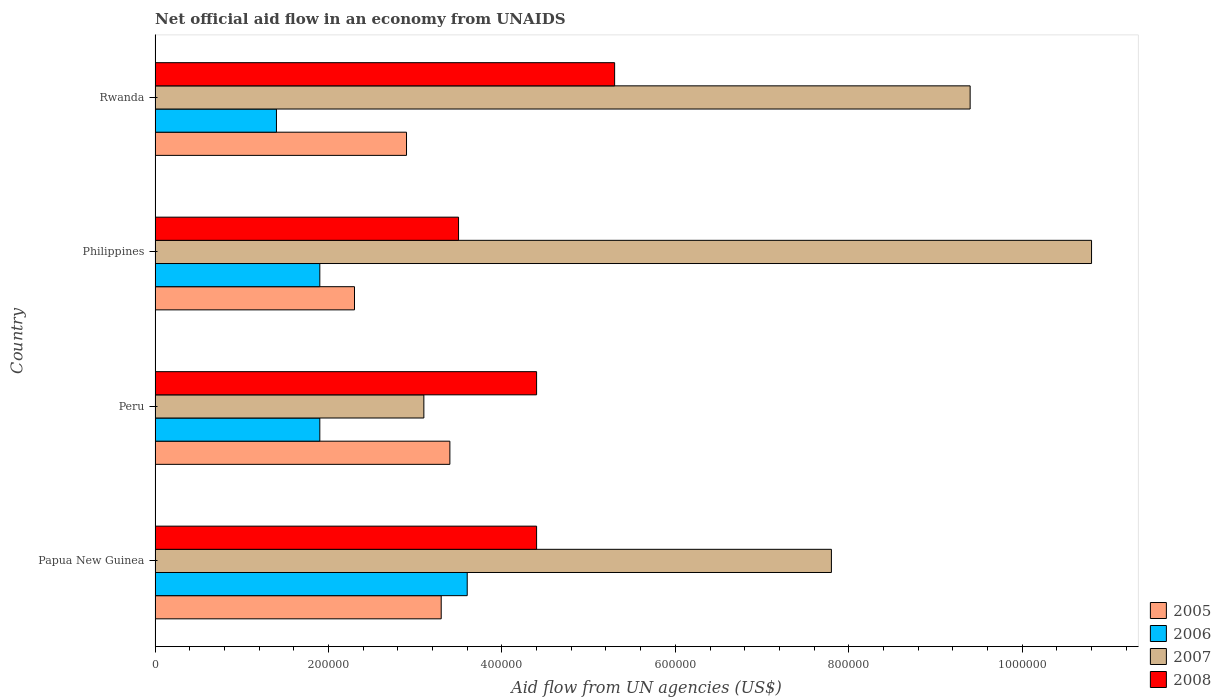How many different coloured bars are there?
Keep it short and to the point. 4. How many bars are there on the 2nd tick from the top?
Offer a very short reply. 4. How many bars are there on the 2nd tick from the bottom?
Your response must be concise. 4. In how many cases, is the number of bars for a given country not equal to the number of legend labels?
Your answer should be very brief. 0. What is the net official aid flow in 2007 in Philippines?
Provide a succinct answer. 1.08e+06. Across all countries, what is the maximum net official aid flow in 2006?
Offer a terse response. 3.60e+05. In which country was the net official aid flow in 2006 maximum?
Your answer should be very brief. Papua New Guinea. What is the total net official aid flow in 2007 in the graph?
Provide a succinct answer. 3.11e+06. What is the difference between the net official aid flow in 2008 in Peru and that in Rwanda?
Your answer should be compact. -9.00e+04. What is the average net official aid flow in 2007 per country?
Keep it short and to the point. 7.78e+05. What is the difference between the net official aid flow in 2008 and net official aid flow in 2007 in Rwanda?
Make the answer very short. -4.10e+05. Is the difference between the net official aid flow in 2008 in Philippines and Rwanda greater than the difference between the net official aid flow in 2007 in Philippines and Rwanda?
Give a very brief answer. No. What is the difference between the highest and the lowest net official aid flow in 2007?
Make the answer very short. 7.70e+05. In how many countries, is the net official aid flow in 2007 greater than the average net official aid flow in 2007 taken over all countries?
Provide a succinct answer. 3. Is the sum of the net official aid flow in 2006 in Peru and Philippines greater than the maximum net official aid flow in 2005 across all countries?
Keep it short and to the point. Yes. Is it the case that in every country, the sum of the net official aid flow in 2007 and net official aid flow in 2005 is greater than the sum of net official aid flow in 2006 and net official aid flow in 2008?
Offer a very short reply. No. What does the 2nd bar from the top in Philippines represents?
Keep it short and to the point. 2007. Are all the bars in the graph horizontal?
Ensure brevity in your answer.  Yes. Are the values on the major ticks of X-axis written in scientific E-notation?
Provide a succinct answer. No. Does the graph contain any zero values?
Provide a succinct answer. No. Does the graph contain grids?
Make the answer very short. No. What is the title of the graph?
Give a very brief answer. Net official aid flow in an economy from UNAIDS. What is the label or title of the X-axis?
Provide a succinct answer. Aid flow from UN agencies (US$). What is the Aid flow from UN agencies (US$) of 2007 in Papua New Guinea?
Your response must be concise. 7.80e+05. What is the Aid flow from UN agencies (US$) in 2008 in Papua New Guinea?
Your answer should be very brief. 4.40e+05. What is the Aid flow from UN agencies (US$) of 2006 in Peru?
Ensure brevity in your answer.  1.90e+05. What is the Aid flow from UN agencies (US$) of 2007 in Peru?
Make the answer very short. 3.10e+05. What is the Aid flow from UN agencies (US$) of 2007 in Philippines?
Make the answer very short. 1.08e+06. What is the Aid flow from UN agencies (US$) in 2007 in Rwanda?
Offer a very short reply. 9.40e+05. What is the Aid flow from UN agencies (US$) of 2008 in Rwanda?
Offer a terse response. 5.30e+05. Across all countries, what is the maximum Aid flow from UN agencies (US$) in 2006?
Offer a terse response. 3.60e+05. Across all countries, what is the maximum Aid flow from UN agencies (US$) of 2007?
Give a very brief answer. 1.08e+06. Across all countries, what is the maximum Aid flow from UN agencies (US$) of 2008?
Provide a succinct answer. 5.30e+05. Across all countries, what is the minimum Aid flow from UN agencies (US$) of 2005?
Your answer should be compact. 2.30e+05. Across all countries, what is the minimum Aid flow from UN agencies (US$) of 2006?
Offer a terse response. 1.40e+05. Across all countries, what is the minimum Aid flow from UN agencies (US$) in 2007?
Make the answer very short. 3.10e+05. Across all countries, what is the minimum Aid flow from UN agencies (US$) of 2008?
Your response must be concise. 3.50e+05. What is the total Aid flow from UN agencies (US$) of 2005 in the graph?
Your response must be concise. 1.19e+06. What is the total Aid flow from UN agencies (US$) in 2006 in the graph?
Provide a short and direct response. 8.80e+05. What is the total Aid flow from UN agencies (US$) of 2007 in the graph?
Your response must be concise. 3.11e+06. What is the total Aid flow from UN agencies (US$) of 2008 in the graph?
Provide a short and direct response. 1.76e+06. What is the difference between the Aid flow from UN agencies (US$) in 2005 in Papua New Guinea and that in Peru?
Make the answer very short. -10000. What is the difference between the Aid flow from UN agencies (US$) in 2005 in Papua New Guinea and that in Philippines?
Keep it short and to the point. 1.00e+05. What is the difference between the Aid flow from UN agencies (US$) in 2005 in Papua New Guinea and that in Rwanda?
Your answer should be very brief. 4.00e+04. What is the difference between the Aid flow from UN agencies (US$) in 2007 in Papua New Guinea and that in Rwanda?
Keep it short and to the point. -1.60e+05. What is the difference between the Aid flow from UN agencies (US$) of 2008 in Papua New Guinea and that in Rwanda?
Your response must be concise. -9.00e+04. What is the difference between the Aid flow from UN agencies (US$) of 2007 in Peru and that in Philippines?
Provide a short and direct response. -7.70e+05. What is the difference between the Aid flow from UN agencies (US$) of 2008 in Peru and that in Philippines?
Give a very brief answer. 9.00e+04. What is the difference between the Aid flow from UN agencies (US$) of 2007 in Peru and that in Rwanda?
Your answer should be compact. -6.30e+05. What is the difference between the Aid flow from UN agencies (US$) of 2008 in Peru and that in Rwanda?
Provide a succinct answer. -9.00e+04. What is the difference between the Aid flow from UN agencies (US$) in 2006 in Philippines and that in Rwanda?
Your answer should be very brief. 5.00e+04. What is the difference between the Aid flow from UN agencies (US$) in 2007 in Philippines and that in Rwanda?
Offer a very short reply. 1.40e+05. What is the difference between the Aid flow from UN agencies (US$) in 2008 in Philippines and that in Rwanda?
Make the answer very short. -1.80e+05. What is the difference between the Aid flow from UN agencies (US$) of 2006 in Papua New Guinea and the Aid flow from UN agencies (US$) of 2007 in Peru?
Make the answer very short. 5.00e+04. What is the difference between the Aid flow from UN agencies (US$) in 2006 in Papua New Guinea and the Aid flow from UN agencies (US$) in 2008 in Peru?
Make the answer very short. -8.00e+04. What is the difference between the Aid flow from UN agencies (US$) of 2005 in Papua New Guinea and the Aid flow from UN agencies (US$) of 2007 in Philippines?
Give a very brief answer. -7.50e+05. What is the difference between the Aid flow from UN agencies (US$) in 2006 in Papua New Guinea and the Aid flow from UN agencies (US$) in 2007 in Philippines?
Your response must be concise. -7.20e+05. What is the difference between the Aid flow from UN agencies (US$) of 2007 in Papua New Guinea and the Aid flow from UN agencies (US$) of 2008 in Philippines?
Keep it short and to the point. 4.30e+05. What is the difference between the Aid flow from UN agencies (US$) in 2005 in Papua New Guinea and the Aid flow from UN agencies (US$) in 2007 in Rwanda?
Make the answer very short. -6.10e+05. What is the difference between the Aid flow from UN agencies (US$) of 2005 in Papua New Guinea and the Aid flow from UN agencies (US$) of 2008 in Rwanda?
Your answer should be compact. -2.00e+05. What is the difference between the Aid flow from UN agencies (US$) of 2006 in Papua New Guinea and the Aid flow from UN agencies (US$) of 2007 in Rwanda?
Give a very brief answer. -5.80e+05. What is the difference between the Aid flow from UN agencies (US$) in 2006 in Papua New Guinea and the Aid flow from UN agencies (US$) in 2008 in Rwanda?
Make the answer very short. -1.70e+05. What is the difference between the Aid flow from UN agencies (US$) of 2007 in Papua New Guinea and the Aid flow from UN agencies (US$) of 2008 in Rwanda?
Provide a short and direct response. 2.50e+05. What is the difference between the Aid flow from UN agencies (US$) in 2005 in Peru and the Aid flow from UN agencies (US$) in 2006 in Philippines?
Offer a very short reply. 1.50e+05. What is the difference between the Aid flow from UN agencies (US$) in 2005 in Peru and the Aid flow from UN agencies (US$) in 2007 in Philippines?
Keep it short and to the point. -7.40e+05. What is the difference between the Aid flow from UN agencies (US$) in 2005 in Peru and the Aid flow from UN agencies (US$) in 2008 in Philippines?
Provide a succinct answer. -10000. What is the difference between the Aid flow from UN agencies (US$) in 2006 in Peru and the Aid flow from UN agencies (US$) in 2007 in Philippines?
Provide a succinct answer. -8.90e+05. What is the difference between the Aid flow from UN agencies (US$) of 2006 in Peru and the Aid flow from UN agencies (US$) of 2008 in Philippines?
Your response must be concise. -1.60e+05. What is the difference between the Aid flow from UN agencies (US$) of 2005 in Peru and the Aid flow from UN agencies (US$) of 2007 in Rwanda?
Provide a succinct answer. -6.00e+05. What is the difference between the Aid flow from UN agencies (US$) in 2006 in Peru and the Aid flow from UN agencies (US$) in 2007 in Rwanda?
Your response must be concise. -7.50e+05. What is the difference between the Aid flow from UN agencies (US$) of 2007 in Peru and the Aid flow from UN agencies (US$) of 2008 in Rwanda?
Offer a very short reply. -2.20e+05. What is the difference between the Aid flow from UN agencies (US$) in 2005 in Philippines and the Aid flow from UN agencies (US$) in 2007 in Rwanda?
Offer a very short reply. -7.10e+05. What is the difference between the Aid flow from UN agencies (US$) of 2006 in Philippines and the Aid flow from UN agencies (US$) of 2007 in Rwanda?
Offer a very short reply. -7.50e+05. What is the difference between the Aid flow from UN agencies (US$) in 2007 in Philippines and the Aid flow from UN agencies (US$) in 2008 in Rwanda?
Provide a short and direct response. 5.50e+05. What is the average Aid flow from UN agencies (US$) of 2005 per country?
Provide a short and direct response. 2.98e+05. What is the average Aid flow from UN agencies (US$) in 2007 per country?
Offer a terse response. 7.78e+05. What is the difference between the Aid flow from UN agencies (US$) of 2005 and Aid flow from UN agencies (US$) of 2006 in Papua New Guinea?
Provide a succinct answer. -3.00e+04. What is the difference between the Aid flow from UN agencies (US$) in 2005 and Aid flow from UN agencies (US$) in 2007 in Papua New Guinea?
Your answer should be very brief. -4.50e+05. What is the difference between the Aid flow from UN agencies (US$) in 2006 and Aid flow from UN agencies (US$) in 2007 in Papua New Guinea?
Your response must be concise. -4.20e+05. What is the difference between the Aid flow from UN agencies (US$) in 2005 and Aid flow from UN agencies (US$) in 2006 in Peru?
Offer a very short reply. 1.50e+05. What is the difference between the Aid flow from UN agencies (US$) of 2005 and Aid flow from UN agencies (US$) of 2007 in Peru?
Provide a succinct answer. 3.00e+04. What is the difference between the Aid flow from UN agencies (US$) of 2005 and Aid flow from UN agencies (US$) of 2008 in Peru?
Keep it short and to the point. -1.00e+05. What is the difference between the Aid flow from UN agencies (US$) of 2006 and Aid flow from UN agencies (US$) of 2007 in Peru?
Offer a very short reply. -1.20e+05. What is the difference between the Aid flow from UN agencies (US$) of 2006 and Aid flow from UN agencies (US$) of 2008 in Peru?
Make the answer very short. -2.50e+05. What is the difference between the Aid flow from UN agencies (US$) in 2007 and Aid flow from UN agencies (US$) in 2008 in Peru?
Offer a very short reply. -1.30e+05. What is the difference between the Aid flow from UN agencies (US$) of 2005 and Aid flow from UN agencies (US$) of 2006 in Philippines?
Make the answer very short. 4.00e+04. What is the difference between the Aid flow from UN agencies (US$) in 2005 and Aid flow from UN agencies (US$) in 2007 in Philippines?
Your response must be concise. -8.50e+05. What is the difference between the Aid flow from UN agencies (US$) of 2005 and Aid flow from UN agencies (US$) of 2008 in Philippines?
Your answer should be very brief. -1.20e+05. What is the difference between the Aid flow from UN agencies (US$) of 2006 and Aid flow from UN agencies (US$) of 2007 in Philippines?
Make the answer very short. -8.90e+05. What is the difference between the Aid flow from UN agencies (US$) of 2006 and Aid flow from UN agencies (US$) of 2008 in Philippines?
Give a very brief answer. -1.60e+05. What is the difference between the Aid flow from UN agencies (US$) of 2007 and Aid flow from UN agencies (US$) of 2008 in Philippines?
Offer a very short reply. 7.30e+05. What is the difference between the Aid flow from UN agencies (US$) in 2005 and Aid flow from UN agencies (US$) in 2007 in Rwanda?
Your answer should be very brief. -6.50e+05. What is the difference between the Aid flow from UN agencies (US$) of 2006 and Aid flow from UN agencies (US$) of 2007 in Rwanda?
Provide a succinct answer. -8.00e+05. What is the difference between the Aid flow from UN agencies (US$) in 2006 and Aid flow from UN agencies (US$) in 2008 in Rwanda?
Offer a very short reply. -3.90e+05. What is the ratio of the Aid flow from UN agencies (US$) of 2005 in Papua New Guinea to that in Peru?
Your response must be concise. 0.97. What is the ratio of the Aid flow from UN agencies (US$) in 2006 in Papua New Guinea to that in Peru?
Provide a succinct answer. 1.89. What is the ratio of the Aid flow from UN agencies (US$) of 2007 in Papua New Guinea to that in Peru?
Keep it short and to the point. 2.52. What is the ratio of the Aid flow from UN agencies (US$) in 2008 in Papua New Guinea to that in Peru?
Make the answer very short. 1. What is the ratio of the Aid flow from UN agencies (US$) of 2005 in Papua New Guinea to that in Philippines?
Provide a succinct answer. 1.43. What is the ratio of the Aid flow from UN agencies (US$) in 2006 in Papua New Guinea to that in Philippines?
Offer a very short reply. 1.89. What is the ratio of the Aid flow from UN agencies (US$) in 2007 in Papua New Guinea to that in Philippines?
Offer a terse response. 0.72. What is the ratio of the Aid flow from UN agencies (US$) in 2008 in Papua New Guinea to that in Philippines?
Keep it short and to the point. 1.26. What is the ratio of the Aid flow from UN agencies (US$) in 2005 in Papua New Guinea to that in Rwanda?
Your answer should be very brief. 1.14. What is the ratio of the Aid flow from UN agencies (US$) of 2006 in Papua New Guinea to that in Rwanda?
Provide a short and direct response. 2.57. What is the ratio of the Aid flow from UN agencies (US$) of 2007 in Papua New Guinea to that in Rwanda?
Your response must be concise. 0.83. What is the ratio of the Aid flow from UN agencies (US$) of 2008 in Papua New Guinea to that in Rwanda?
Offer a very short reply. 0.83. What is the ratio of the Aid flow from UN agencies (US$) in 2005 in Peru to that in Philippines?
Your response must be concise. 1.48. What is the ratio of the Aid flow from UN agencies (US$) in 2006 in Peru to that in Philippines?
Offer a terse response. 1. What is the ratio of the Aid flow from UN agencies (US$) in 2007 in Peru to that in Philippines?
Provide a succinct answer. 0.29. What is the ratio of the Aid flow from UN agencies (US$) of 2008 in Peru to that in Philippines?
Your answer should be compact. 1.26. What is the ratio of the Aid flow from UN agencies (US$) of 2005 in Peru to that in Rwanda?
Keep it short and to the point. 1.17. What is the ratio of the Aid flow from UN agencies (US$) in 2006 in Peru to that in Rwanda?
Make the answer very short. 1.36. What is the ratio of the Aid flow from UN agencies (US$) in 2007 in Peru to that in Rwanda?
Provide a succinct answer. 0.33. What is the ratio of the Aid flow from UN agencies (US$) in 2008 in Peru to that in Rwanda?
Your answer should be very brief. 0.83. What is the ratio of the Aid flow from UN agencies (US$) of 2005 in Philippines to that in Rwanda?
Provide a succinct answer. 0.79. What is the ratio of the Aid flow from UN agencies (US$) of 2006 in Philippines to that in Rwanda?
Your answer should be very brief. 1.36. What is the ratio of the Aid flow from UN agencies (US$) in 2007 in Philippines to that in Rwanda?
Offer a very short reply. 1.15. What is the ratio of the Aid flow from UN agencies (US$) in 2008 in Philippines to that in Rwanda?
Keep it short and to the point. 0.66. What is the difference between the highest and the second highest Aid flow from UN agencies (US$) of 2005?
Offer a very short reply. 10000. What is the difference between the highest and the second highest Aid flow from UN agencies (US$) in 2007?
Give a very brief answer. 1.40e+05. What is the difference between the highest and the second highest Aid flow from UN agencies (US$) of 2008?
Your response must be concise. 9.00e+04. What is the difference between the highest and the lowest Aid flow from UN agencies (US$) of 2005?
Your response must be concise. 1.10e+05. What is the difference between the highest and the lowest Aid flow from UN agencies (US$) of 2007?
Give a very brief answer. 7.70e+05. What is the difference between the highest and the lowest Aid flow from UN agencies (US$) in 2008?
Your answer should be compact. 1.80e+05. 